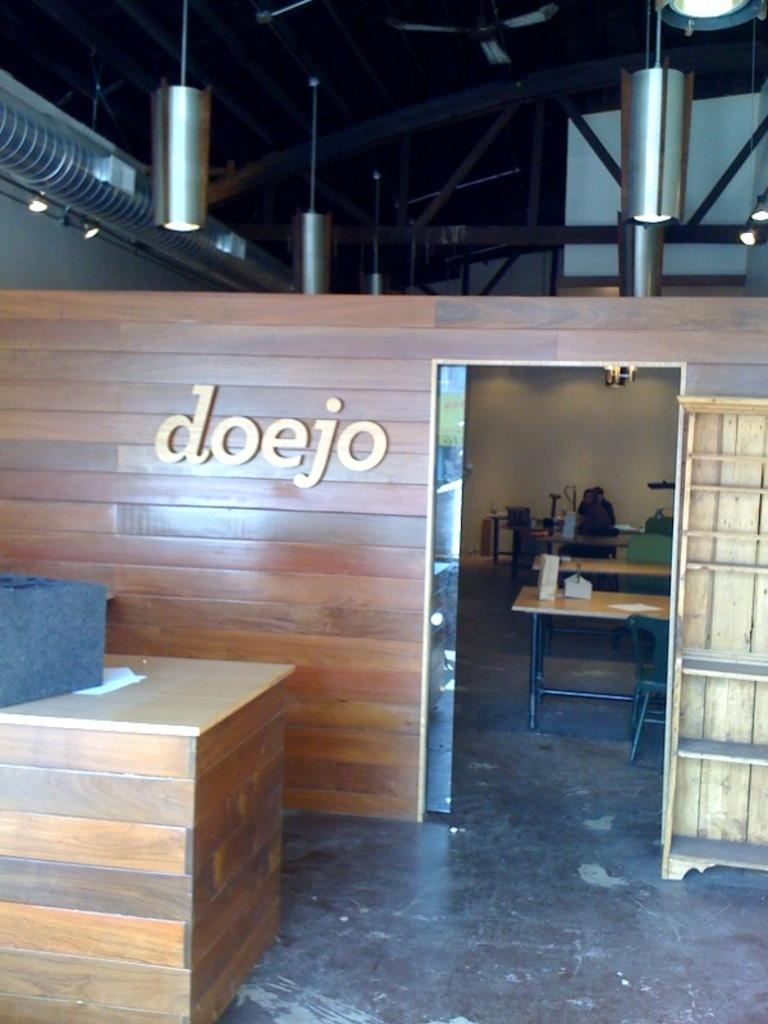Provide a one-sentence caption for the provided image. A counter is in front of a room that is labeled doejo. 